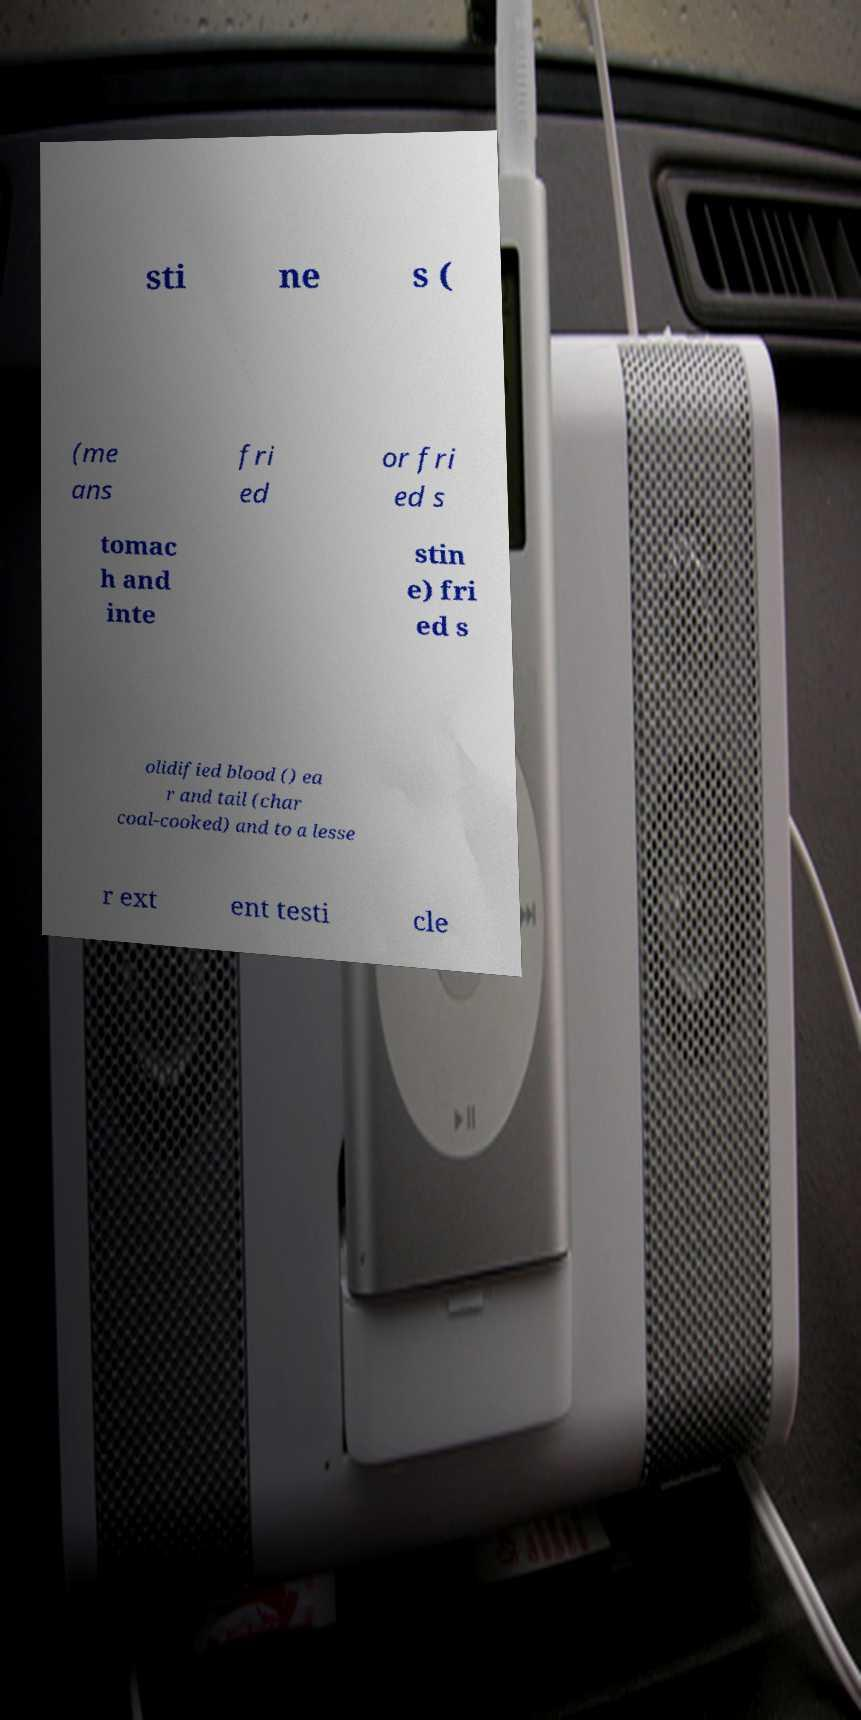For documentation purposes, I need the text within this image transcribed. Could you provide that? sti ne s ( (me ans fri ed or fri ed s tomac h and inte stin e) fri ed s olidified blood () ea r and tail (char coal-cooked) and to a lesse r ext ent testi cle 